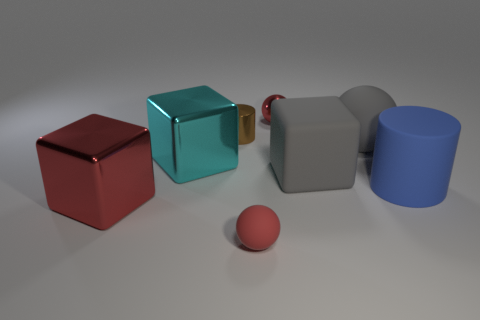Add 2 green cubes. How many objects exist? 10 Subtract all cylinders. How many objects are left? 6 Add 4 cyan blocks. How many cyan blocks are left? 5 Add 4 big yellow matte cubes. How many big yellow matte cubes exist? 4 Subtract 1 blue cylinders. How many objects are left? 7 Subtract all red metallic things. Subtract all large red shiny cubes. How many objects are left? 5 